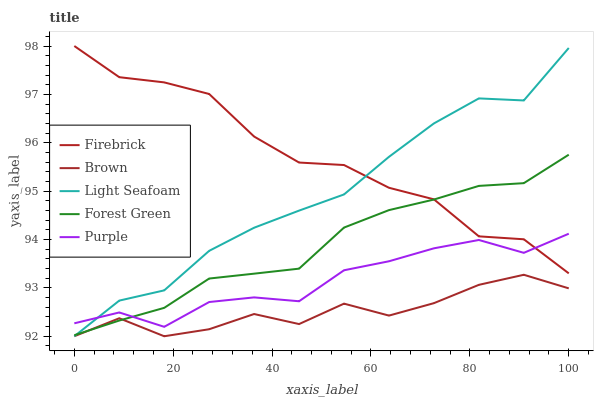Does Brown have the minimum area under the curve?
Answer yes or no. Yes. Does Firebrick have the maximum area under the curve?
Answer yes or no. Yes. Does Firebrick have the minimum area under the curve?
Answer yes or no. No. Does Brown have the maximum area under the curve?
Answer yes or no. No. Is Forest Green the smoothest?
Answer yes or no. Yes. Is Firebrick the roughest?
Answer yes or no. Yes. Is Brown the smoothest?
Answer yes or no. No. Is Brown the roughest?
Answer yes or no. No. Does Brown have the lowest value?
Answer yes or no. Yes. Does Firebrick have the lowest value?
Answer yes or no. No. Does Firebrick have the highest value?
Answer yes or no. Yes. Does Brown have the highest value?
Answer yes or no. No. Is Brown less than Firebrick?
Answer yes or no. Yes. Is Purple greater than Brown?
Answer yes or no. Yes. Does Light Seafoam intersect Forest Green?
Answer yes or no. Yes. Is Light Seafoam less than Forest Green?
Answer yes or no. No. Is Light Seafoam greater than Forest Green?
Answer yes or no. No. Does Brown intersect Firebrick?
Answer yes or no. No. 